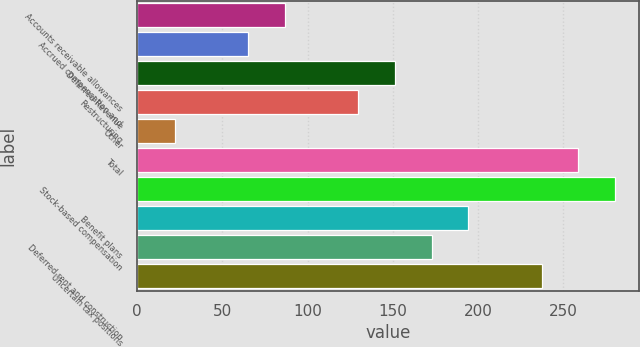<chart> <loc_0><loc_0><loc_500><loc_500><bar_chart><fcel>Accounts receivable allowances<fcel>Accrued compensation and<fcel>Deferred Revenue<fcel>Restructuring<fcel>Other<fcel>Total<fcel>Stock-based compensation<fcel>Benefit plans<fcel>Deferred rent and construction<fcel>Uncertain tax positions<nl><fcel>86.5<fcel>64.95<fcel>151.15<fcel>129.6<fcel>21.85<fcel>258.9<fcel>280.45<fcel>194.25<fcel>172.7<fcel>237.35<nl></chart> 